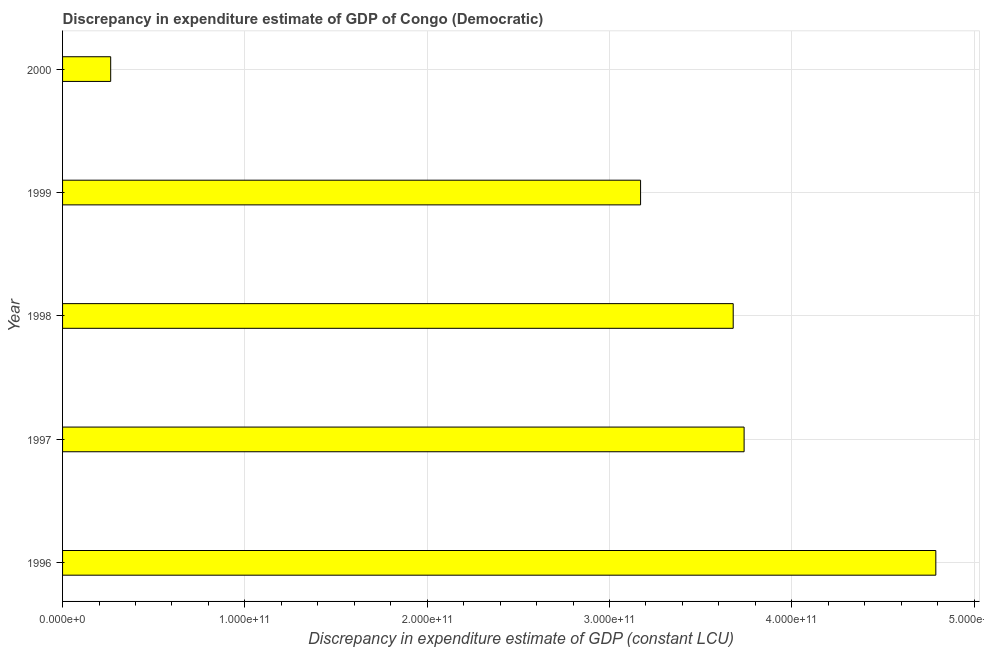What is the title of the graph?
Offer a very short reply. Discrepancy in expenditure estimate of GDP of Congo (Democratic). What is the label or title of the X-axis?
Keep it short and to the point. Discrepancy in expenditure estimate of GDP (constant LCU). What is the discrepancy in expenditure estimate of gdp in 2000?
Your answer should be very brief. 2.64e+1. Across all years, what is the maximum discrepancy in expenditure estimate of gdp?
Your answer should be very brief. 4.79e+11. Across all years, what is the minimum discrepancy in expenditure estimate of gdp?
Offer a very short reply. 2.64e+1. In which year was the discrepancy in expenditure estimate of gdp maximum?
Offer a very short reply. 1996. What is the sum of the discrepancy in expenditure estimate of gdp?
Give a very brief answer. 1.56e+12. What is the difference between the discrepancy in expenditure estimate of gdp in 1997 and 2000?
Offer a very short reply. 3.47e+11. What is the average discrepancy in expenditure estimate of gdp per year?
Ensure brevity in your answer.  3.13e+11. What is the median discrepancy in expenditure estimate of gdp?
Your response must be concise. 3.68e+11. Do a majority of the years between 1999 and 1997 (inclusive) have discrepancy in expenditure estimate of gdp greater than 320000000000 LCU?
Provide a short and direct response. Yes. What is the ratio of the discrepancy in expenditure estimate of gdp in 1998 to that in 1999?
Give a very brief answer. 1.16. What is the difference between the highest and the second highest discrepancy in expenditure estimate of gdp?
Provide a short and direct response. 1.05e+11. Is the sum of the discrepancy in expenditure estimate of gdp in 1997 and 1998 greater than the maximum discrepancy in expenditure estimate of gdp across all years?
Give a very brief answer. Yes. What is the difference between the highest and the lowest discrepancy in expenditure estimate of gdp?
Provide a succinct answer. 4.53e+11. How many years are there in the graph?
Provide a short and direct response. 5. What is the difference between two consecutive major ticks on the X-axis?
Your answer should be compact. 1.00e+11. What is the Discrepancy in expenditure estimate of GDP (constant LCU) in 1996?
Provide a succinct answer. 4.79e+11. What is the Discrepancy in expenditure estimate of GDP (constant LCU) of 1997?
Provide a succinct answer. 3.74e+11. What is the Discrepancy in expenditure estimate of GDP (constant LCU) in 1998?
Provide a short and direct response. 3.68e+11. What is the Discrepancy in expenditure estimate of GDP (constant LCU) of 1999?
Ensure brevity in your answer.  3.17e+11. What is the Discrepancy in expenditure estimate of GDP (constant LCU) in 2000?
Provide a succinct answer. 2.64e+1. What is the difference between the Discrepancy in expenditure estimate of GDP (constant LCU) in 1996 and 1997?
Your response must be concise. 1.05e+11. What is the difference between the Discrepancy in expenditure estimate of GDP (constant LCU) in 1996 and 1998?
Make the answer very short. 1.11e+11. What is the difference between the Discrepancy in expenditure estimate of GDP (constant LCU) in 1996 and 1999?
Ensure brevity in your answer.  1.62e+11. What is the difference between the Discrepancy in expenditure estimate of GDP (constant LCU) in 1996 and 2000?
Provide a succinct answer. 4.53e+11. What is the difference between the Discrepancy in expenditure estimate of GDP (constant LCU) in 1997 and 1998?
Keep it short and to the point. 5.98e+09. What is the difference between the Discrepancy in expenditure estimate of GDP (constant LCU) in 1997 and 1999?
Keep it short and to the point. 5.68e+1. What is the difference between the Discrepancy in expenditure estimate of GDP (constant LCU) in 1997 and 2000?
Offer a terse response. 3.47e+11. What is the difference between the Discrepancy in expenditure estimate of GDP (constant LCU) in 1998 and 1999?
Your answer should be very brief. 5.08e+1. What is the difference between the Discrepancy in expenditure estimate of GDP (constant LCU) in 1998 and 2000?
Give a very brief answer. 3.41e+11. What is the difference between the Discrepancy in expenditure estimate of GDP (constant LCU) in 1999 and 2000?
Provide a short and direct response. 2.91e+11. What is the ratio of the Discrepancy in expenditure estimate of GDP (constant LCU) in 1996 to that in 1997?
Your answer should be compact. 1.28. What is the ratio of the Discrepancy in expenditure estimate of GDP (constant LCU) in 1996 to that in 1998?
Your answer should be compact. 1.3. What is the ratio of the Discrepancy in expenditure estimate of GDP (constant LCU) in 1996 to that in 1999?
Offer a very short reply. 1.51. What is the ratio of the Discrepancy in expenditure estimate of GDP (constant LCU) in 1996 to that in 2000?
Make the answer very short. 18.14. What is the ratio of the Discrepancy in expenditure estimate of GDP (constant LCU) in 1997 to that in 1998?
Make the answer very short. 1.02. What is the ratio of the Discrepancy in expenditure estimate of GDP (constant LCU) in 1997 to that in 1999?
Offer a very short reply. 1.18. What is the ratio of the Discrepancy in expenditure estimate of GDP (constant LCU) in 1997 to that in 2000?
Offer a very short reply. 14.16. What is the ratio of the Discrepancy in expenditure estimate of GDP (constant LCU) in 1998 to that in 1999?
Your answer should be compact. 1.16. What is the ratio of the Discrepancy in expenditure estimate of GDP (constant LCU) in 1998 to that in 2000?
Offer a terse response. 13.93. What is the ratio of the Discrepancy in expenditure estimate of GDP (constant LCU) in 1999 to that in 2000?
Keep it short and to the point. 12.01. 